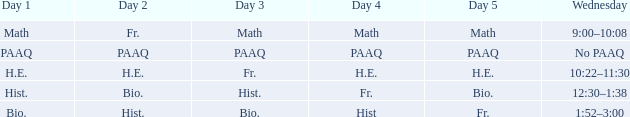What is the day 1 when the day 3 is math? Math. 